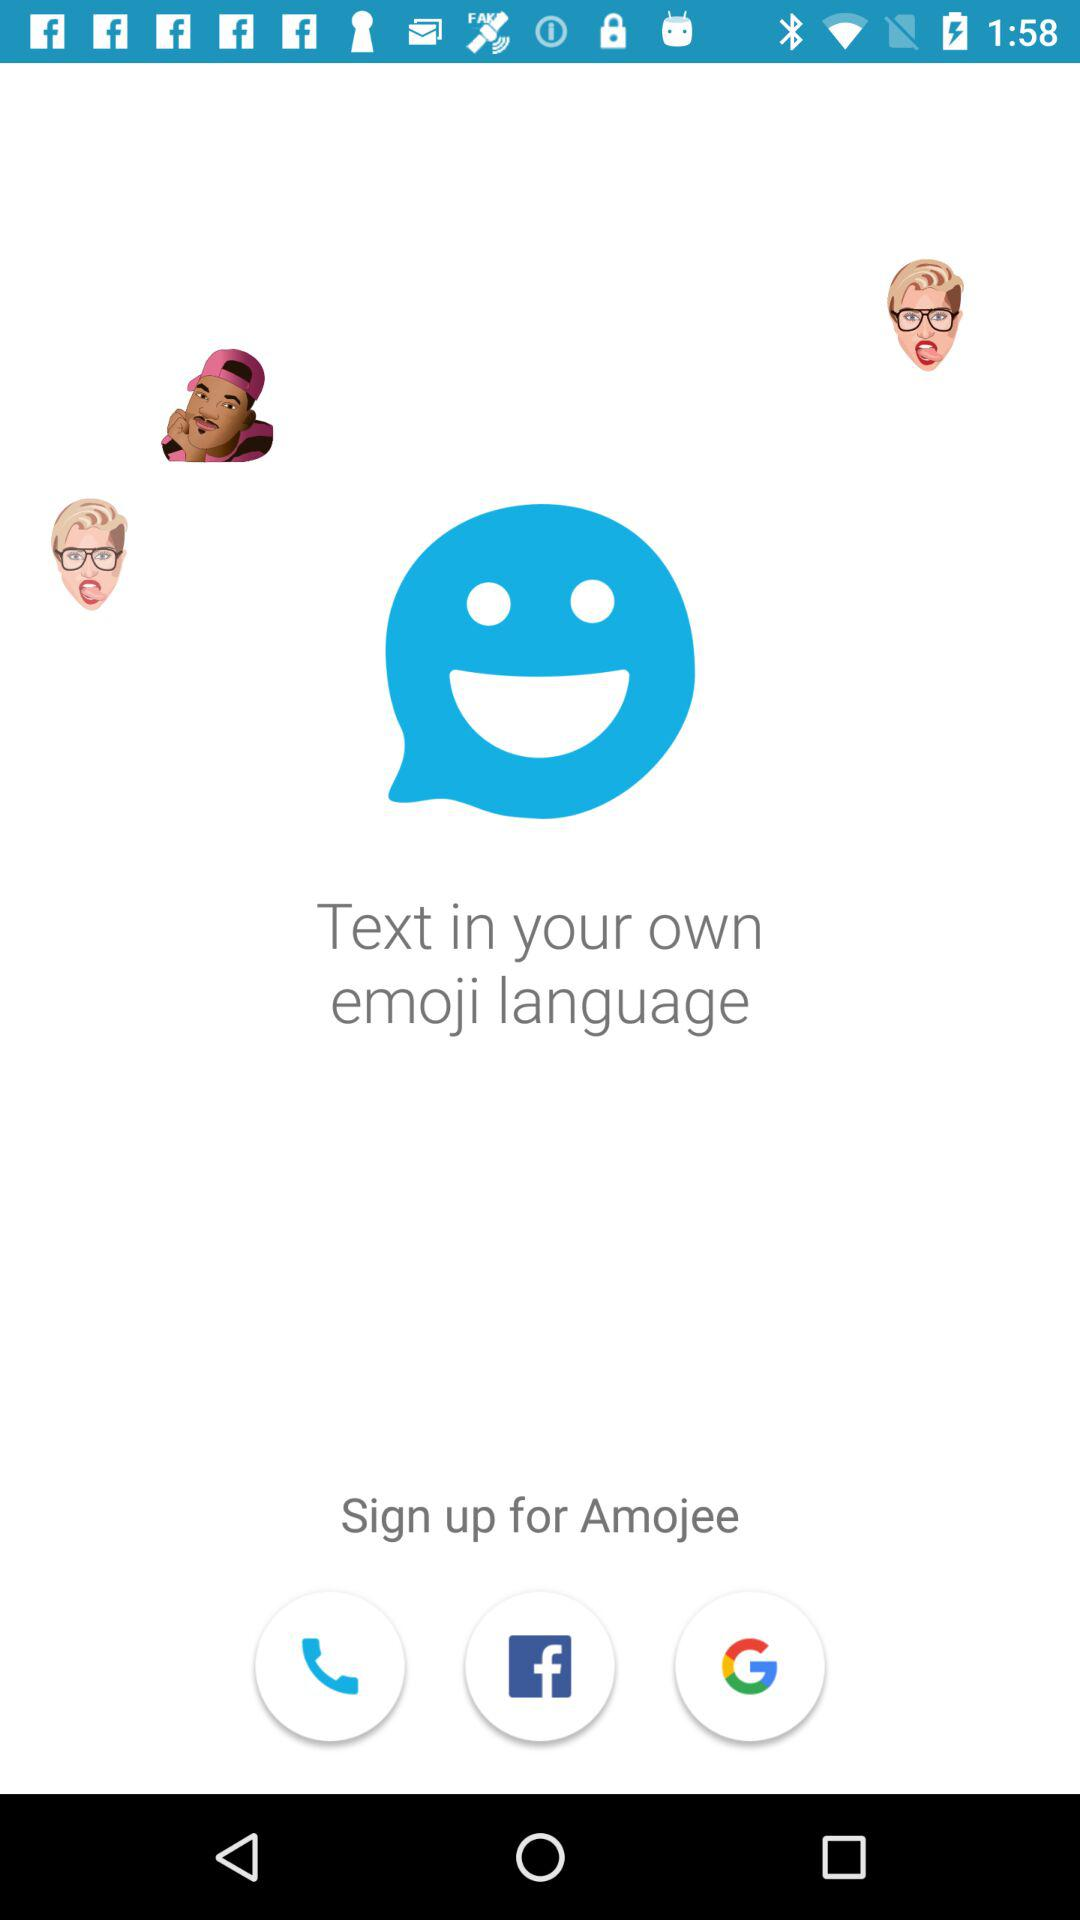What accounts can I use to sign up? You can use to sign up with Facebook and Google. 